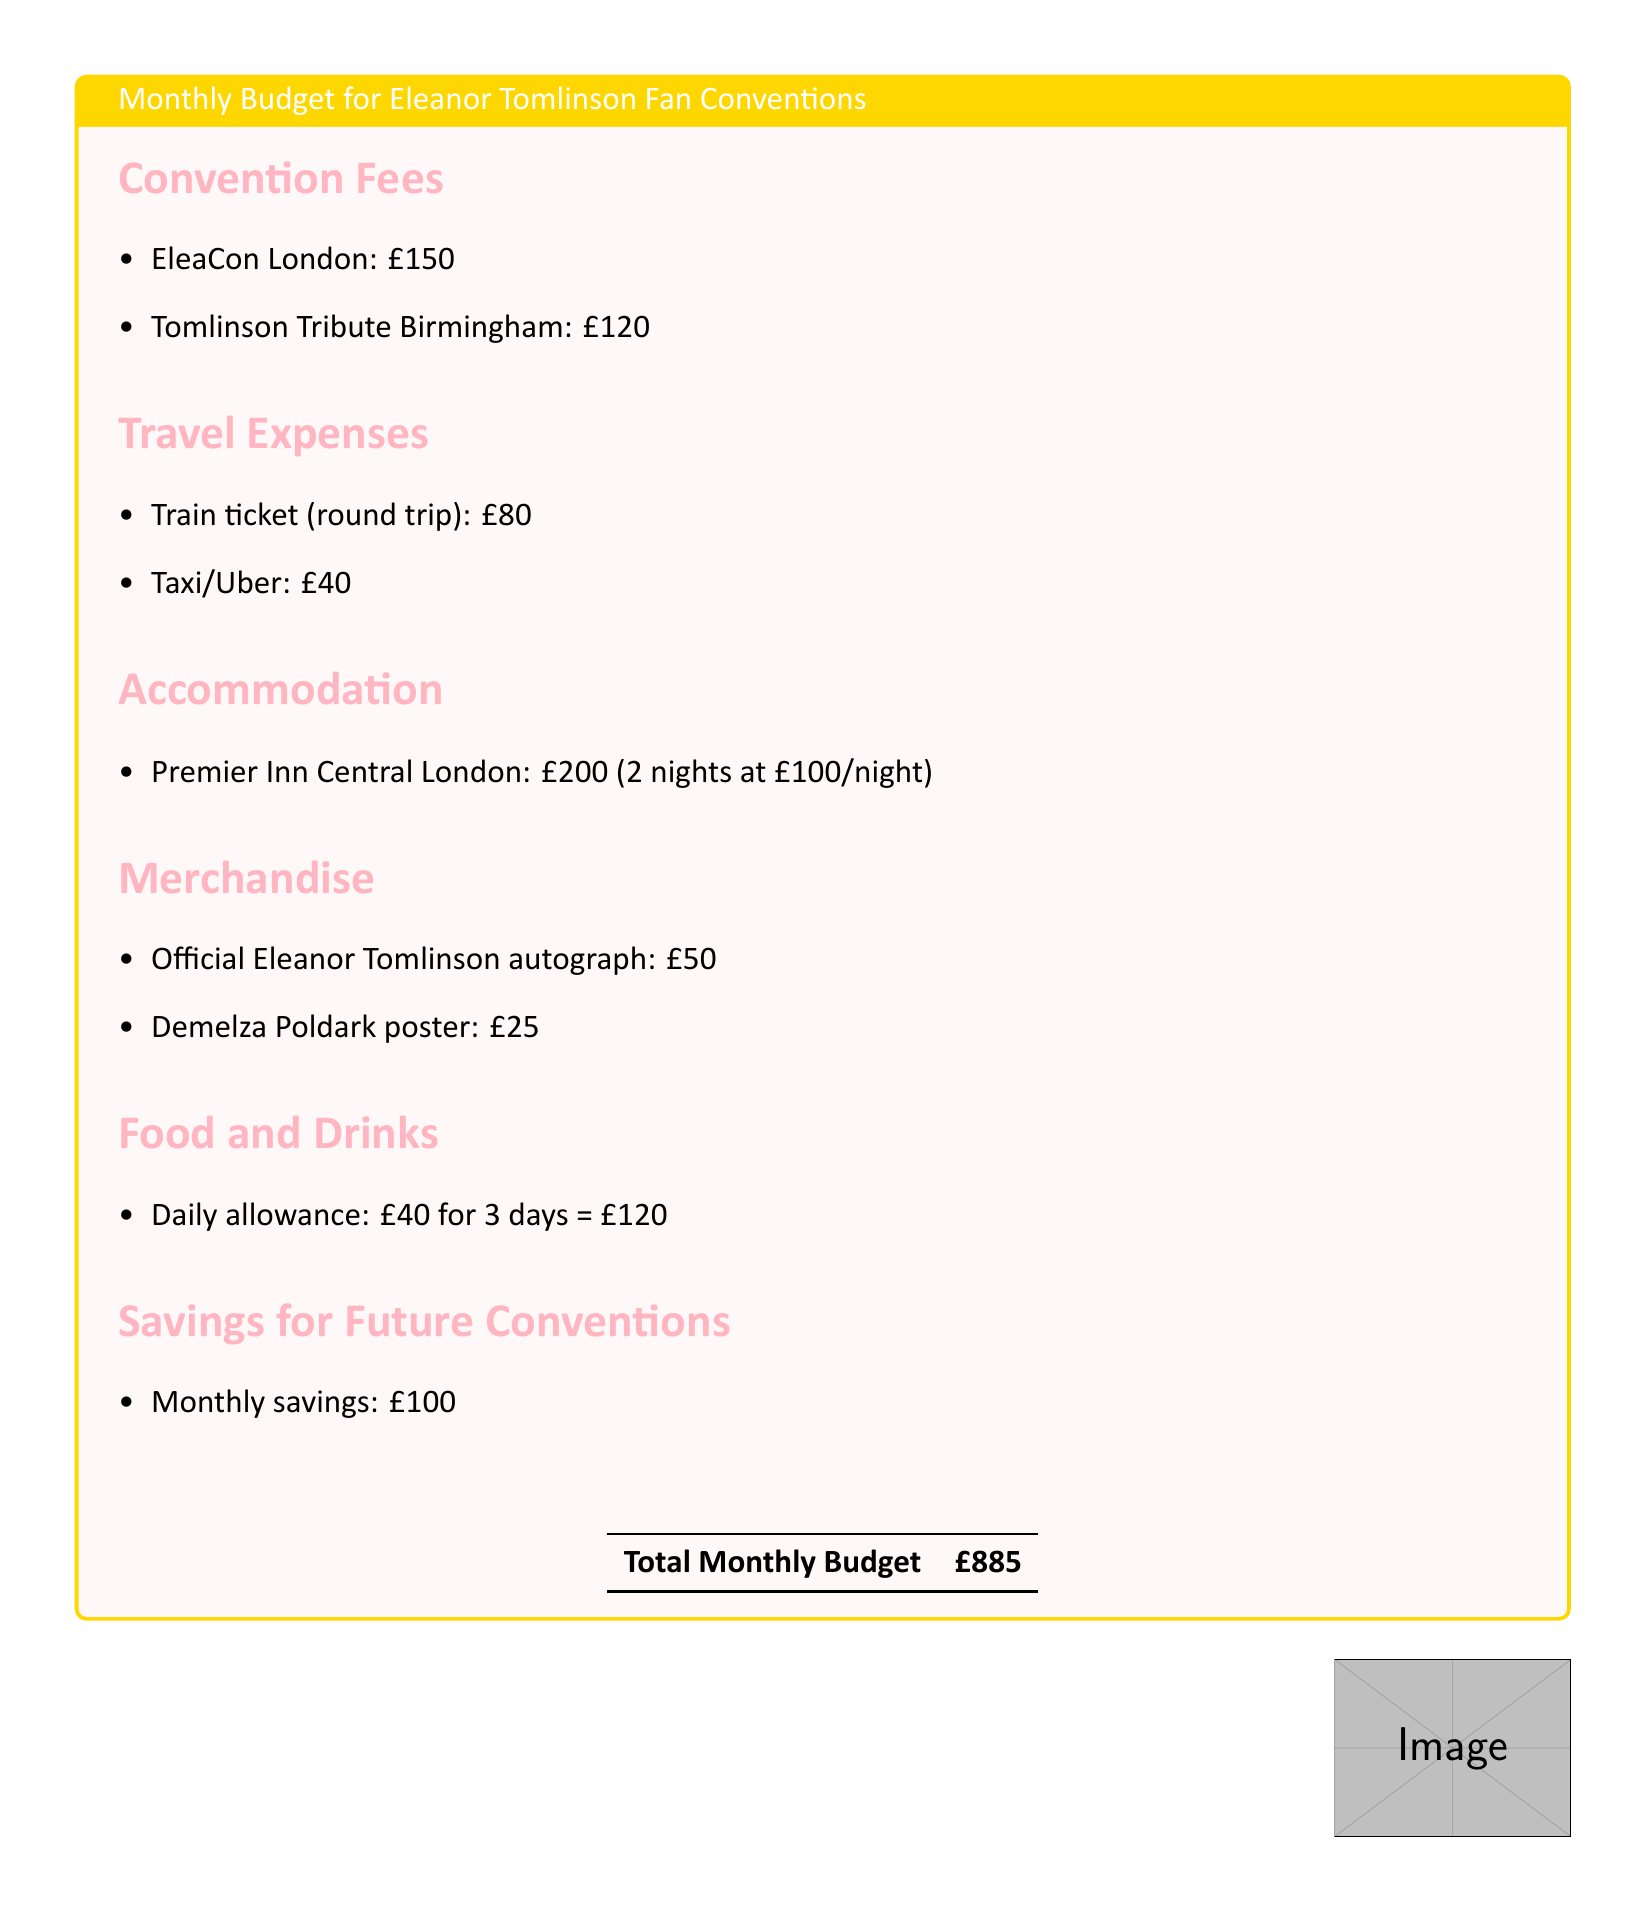What is the cost of EleaCon London? EleaCon London is listed under Convention Fees with a specific amount detailed in the document.
Answer: £150 What is the round-trip train ticket cost? The round-trip train ticket is specified under Travel Expenses, revealing its cost explicitly.
Answer: £80 How much is the daily food allowance? A Daily allowance for food and drinks is provided, which directly states the amount.
Answer: £40 Total savings set aside for future conventions? The document indicates a specific monthly savings amount intended for future events.
Answer: £100 What is the total monthly budget? The total monthly budget is summarized at the end of the document, combining all expenses and savings.
Answer: £885 What is the cost of a Demelza Poldark poster? The cost of the Demelza Poldark poster is specified under Merchandise in the budget breakdown.
Answer: £25 How many nights will be spent at the Premier Inn? The accommodation section mentions how long the stay will be at the hotel, which reveals the number of nights.
Answer: 2 nights What is the total cost of the taxi/Uber? The taxi/Uber cost for travel is listed in the Travel Expenses section, indicating the total amount for this category.
Answer: £40 